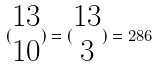<formula> <loc_0><loc_0><loc_500><loc_500>( \begin{matrix} 1 3 \\ 1 0 \end{matrix} ) = ( \begin{matrix} 1 3 \\ 3 \end{matrix} ) = 2 8 6</formula> 